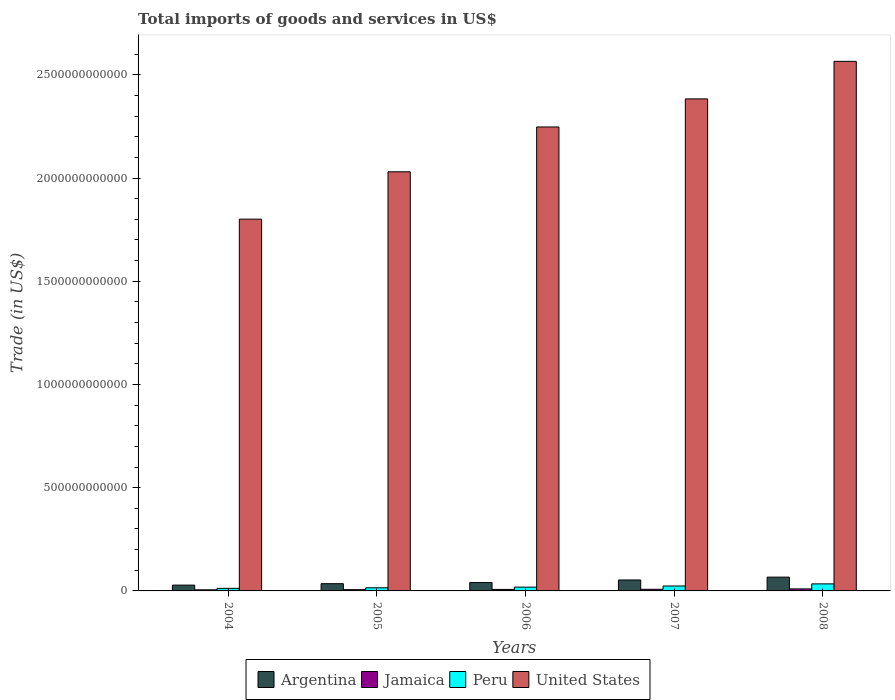How many groups of bars are there?
Offer a very short reply. 5. Are the number of bars per tick equal to the number of legend labels?
Your answer should be compact. Yes. Are the number of bars on each tick of the X-axis equal?
Your answer should be compact. Yes. How many bars are there on the 3rd tick from the right?
Your response must be concise. 4. What is the label of the 2nd group of bars from the left?
Your response must be concise. 2005. What is the total imports of goods and services in Peru in 2006?
Provide a short and direct response. 1.83e+1. Across all years, what is the maximum total imports of goods and services in Jamaica?
Ensure brevity in your answer.  9.80e+09. Across all years, what is the minimum total imports of goods and services in Jamaica?
Provide a short and direct response. 5.26e+09. In which year was the total imports of goods and services in Peru minimum?
Offer a very short reply. 2004. What is the total total imports of goods and services in Argentina in the graph?
Ensure brevity in your answer.  2.24e+11. What is the difference between the total imports of goods and services in Argentina in 2004 and that in 2008?
Keep it short and to the point. -3.87e+1. What is the difference between the total imports of goods and services in United States in 2008 and the total imports of goods and services in Peru in 2004?
Your answer should be compact. 2.55e+12. What is the average total imports of goods and services in Peru per year?
Your response must be concise. 2.08e+1. In the year 2004, what is the difference between the total imports of goods and services in United States and total imports of goods and services in Jamaica?
Give a very brief answer. 1.80e+12. In how many years, is the total imports of goods and services in Peru greater than 1900000000000 US$?
Provide a succinct answer. 0. What is the ratio of the total imports of goods and services in Jamaica in 2004 to that in 2008?
Make the answer very short. 0.54. What is the difference between the highest and the second highest total imports of goods and services in United States?
Your answer should be very brief. 1.82e+11. What is the difference between the highest and the lowest total imports of goods and services in Argentina?
Keep it short and to the point. 3.87e+1. In how many years, is the total imports of goods and services in United States greater than the average total imports of goods and services in United States taken over all years?
Give a very brief answer. 3. Is the sum of the total imports of goods and services in United States in 2007 and 2008 greater than the maximum total imports of goods and services in Argentina across all years?
Keep it short and to the point. Yes. Are all the bars in the graph horizontal?
Make the answer very short. No. How many years are there in the graph?
Your response must be concise. 5. What is the difference between two consecutive major ticks on the Y-axis?
Your response must be concise. 5.00e+11. Does the graph contain any zero values?
Keep it short and to the point. No. How many legend labels are there?
Your response must be concise. 4. How are the legend labels stacked?
Keep it short and to the point. Horizontal. What is the title of the graph?
Keep it short and to the point. Total imports of goods and services in US$. Does "Euro area" appear as one of the legend labels in the graph?
Your response must be concise. No. What is the label or title of the X-axis?
Provide a succinct answer. Years. What is the label or title of the Y-axis?
Your answer should be compact. Trade (in US$). What is the Trade (in US$) in Argentina in 2004?
Provide a succinct answer. 2.81e+1. What is the Trade (in US$) of Jamaica in 2004?
Offer a very short reply. 5.26e+09. What is the Trade (in US$) of Peru in 2004?
Make the answer very short. 1.24e+1. What is the Trade (in US$) in United States in 2004?
Offer a terse response. 1.80e+12. What is the Trade (in US$) in Argentina in 2005?
Keep it short and to the point. 3.51e+1. What is the Trade (in US$) of Jamaica in 2005?
Offer a terse response. 6.19e+09. What is the Trade (in US$) of Peru in 2005?
Your response must be concise. 1.52e+1. What is the Trade (in US$) in United States in 2005?
Offer a very short reply. 2.03e+12. What is the Trade (in US$) of Argentina in 2006?
Your answer should be very brief. 4.09e+1. What is the Trade (in US$) of Jamaica in 2006?
Your answer should be very brief. 7.22e+09. What is the Trade (in US$) of Peru in 2006?
Offer a terse response. 1.83e+1. What is the Trade (in US$) of United States in 2006?
Provide a short and direct response. 2.25e+12. What is the Trade (in US$) in Argentina in 2007?
Ensure brevity in your answer.  5.30e+1. What is the Trade (in US$) of Jamaica in 2007?
Your answer should be compact. 7.89e+09. What is the Trade (in US$) of Peru in 2007?
Provide a succinct answer. 2.39e+1. What is the Trade (in US$) in United States in 2007?
Your answer should be very brief. 2.38e+12. What is the Trade (in US$) of Argentina in 2008?
Your answer should be very brief. 6.68e+1. What is the Trade (in US$) in Jamaica in 2008?
Offer a very short reply. 9.80e+09. What is the Trade (in US$) in Peru in 2008?
Provide a succinct answer. 3.41e+1. What is the Trade (in US$) in United States in 2008?
Your response must be concise. 2.57e+12. Across all years, what is the maximum Trade (in US$) of Argentina?
Your answer should be very brief. 6.68e+1. Across all years, what is the maximum Trade (in US$) of Jamaica?
Keep it short and to the point. 9.80e+09. Across all years, what is the maximum Trade (in US$) in Peru?
Your answer should be very brief. 3.41e+1. Across all years, what is the maximum Trade (in US$) in United States?
Your answer should be very brief. 2.57e+12. Across all years, what is the minimum Trade (in US$) in Argentina?
Your response must be concise. 2.81e+1. Across all years, what is the minimum Trade (in US$) in Jamaica?
Keep it short and to the point. 5.26e+09. Across all years, what is the minimum Trade (in US$) of Peru?
Keep it short and to the point. 1.24e+1. Across all years, what is the minimum Trade (in US$) of United States?
Keep it short and to the point. 1.80e+12. What is the total Trade (in US$) in Argentina in the graph?
Offer a very short reply. 2.24e+11. What is the total Trade (in US$) of Jamaica in the graph?
Provide a succinct answer. 3.63e+1. What is the total Trade (in US$) in Peru in the graph?
Make the answer very short. 1.04e+11. What is the total Trade (in US$) in United States in the graph?
Your answer should be compact. 1.10e+13. What is the difference between the Trade (in US$) in Argentina in 2004 and that in 2005?
Your response must be concise. -6.96e+09. What is the difference between the Trade (in US$) in Jamaica in 2004 and that in 2005?
Offer a very short reply. -9.31e+08. What is the difference between the Trade (in US$) in Peru in 2004 and that in 2005?
Your response must be concise. -2.80e+09. What is the difference between the Trade (in US$) of United States in 2004 and that in 2005?
Make the answer very short. -2.29e+11. What is the difference between the Trade (in US$) of Argentina in 2004 and that in 2006?
Your answer should be compact. -1.27e+1. What is the difference between the Trade (in US$) of Jamaica in 2004 and that in 2006?
Make the answer very short. -1.96e+09. What is the difference between the Trade (in US$) in Peru in 2004 and that in 2006?
Your answer should be very brief. -5.91e+09. What is the difference between the Trade (in US$) in United States in 2004 and that in 2006?
Provide a succinct answer. -4.47e+11. What is the difference between the Trade (in US$) in Argentina in 2004 and that in 2007?
Provide a succinct answer. -2.49e+1. What is the difference between the Trade (in US$) in Jamaica in 2004 and that in 2007?
Your answer should be very brief. -2.63e+09. What is the difference between the Trade (in US$) of Peru in 2004 and that in 2007?
Offer a very short reply. -1.15e+1. What is the difference between the Trade (in US$) of United States in 2004 and that in 2007?
Provide a short and direct response. -5.82e+11. What is the difference between the Trade (in US$) of Argentina in 2004 and that in 2008?
Give a very brief answer. -3.87e+1. What is the difference between the Trade (in US$) of Jamaica in 2004 and that in 2008?
Keep it short and to the point. -4.54e+09. What is the difference between the Trade (in US$) of Peru in 2004 and that in 2008?
Give a very brief answer. -2.17e+1. What is the difference between the Trade (in US$) in United States in 2004 and that in 2008?
Offer a very short reply. -7.64e+11. What is the difference between the Trade (in US$) of Argentina in 2005 and that in 2006?
Your answer should be very brief. -5.76e+09. What is the difference between the Trade (in US$) in Jamaica in 2005 and that in 2006?
Make the answer very short. -1.03e+09. What is the difference between the Trade (in US$) in Peru in 2005 and that in 2006?
Provide a succinct answer. -3.11e+09. What is the difference between the Trade (in US$) of United States in 2005 and that in 2006?
Keep it short and to the point. -2.17e+11. What is the difference between the Trade (in US$) in Argentina in 2005 and that in 2007?
Your answer should be compact. -1.80e+1. What is the difference between the Trade (in US$) of Jamaica in 2005 and that in 2007?
Your answer should be compact. -1.70e+09. What is the difference between the Trade (in US$) of Peru in 2005 and that in 2007?
Offer a very short reply. -8.67e+09. What is the difference between the Trade (in US$) of United States in 2005 and that in 2007?
Make the answer very short. -3.53e+11. What is the difference between the Trade (in US$) in Argentina in 2005 and that in 2008?
Provide a short and direct response. -3.17e+1. What is the difference between the Trade (in US$) in Jamaica in 2005 and that in 2008?
Your answer should be very brief. -3.61e+09. What is the difference between the Trade (in US$) of Peru in 2005 and that in 2008?
Your response must be concise. -1.89e+1. What is the difference between the Trade (in US$) in United States in 2005 and that in 2008?
Ensure brevity in your answer.  -5.35e+11. What is the difference between the Trade (in US$) in Argentina in 2006 and that in 2007?
Offer a terse response. -1.22e+1. What is the difference between the Trade (in US$) of Jamaica in 2006 and that in 2007?
Provide a short and direct response. -6.72e+08. What is the difference between the Trade (in US$) of Peru in 2006 and that in 2007?
Your response must be concise. -5.56e+09. What is the difference between the Trade (in US$) of United States in 2006 and that in 2007?
Ensure brevity in your answer.  -1.36e+11. What is the difference between the Trade (in US$) of Argentina in 2006 and that in 2008?
Your answer should be very brief. -2.59e+1. What is the difference between the Trade (in US$) in Jamaica in 2006 and that in 2008?
Offer a very short reply. -2.58e+09. What is the difference between the Trade (in US$) of Peru in 2006 and that in 2008?
Your answer should be compact. -1.58e+1. What is the difference between the Trade (in US$) of United States in 2006 and that in 2008?
Ensure brevity in your answer.  -3.18e+11. What is the difference between the Trade (in US$) in Argentina in 2007 and that in 2008?
Offer a terse response. -1.37e+1. What is the difference between the Trade (in US$) of Jamaica in 2007 and that in 2008?
Offer a terse response. -1.91e+09. What is the difference between the Trade (in US$) in Peru in 2007 and that in 2008?
Offer a terse response. -1.02e+1. What is the difference between the Trade (in US$) in United States in 2007 and that in 2008?
Provide a short and direct response. -1.82e+11. What is the difference between the Trade (in US$) of Argentina in 2004 and the Trade (in US$) of Jamaica in 2005?
Your response must be concise. 2.20e+1. What is the difference between the Trade (in US$) in Argentina in 2004 and the Trade (in US$) in Peru in 2005?
Keep it short and to the point. 1.29e+1. What is the difference between the Trade (in US$) in Argentina in 2004 and the Trade (in US$) in United States in 2005?
Give a very brief answer. -2.00e+12. What is the difference between the Trade (in US$) of Jamaica in 2004 and the Trade (in US$) of Peru in 2005?
Offer a very short reply. -9.96e+09. What is the difference between the Trade (in US$) in Jamaica in 2004 and the Trade (in US$) in United States in 2005?
Ensure brevity in your answer.  -2.02e+12. What is the difference between the Trade (in US$) of Peru in 2004 and the Trade (in US$) of United States in 2005?
Keep it short and to the point. -2.02e+12. What is the difference between the Trade (in US$) of Argentina in 2004 and the Trade (in US$) of Jamaica in 2006?
Your answer should be compact. 2.09e+1. What is the difference between the Trade (in US$) in Argentina in 2004 and the Trade (in US$) in Peru in 2006?
Your answer should be very brief. 9.81e+09. What is the difference between the Trade (in US$) of Argentina in 2004 and the Trade (in US$) of United States in 2006?
Provide a short and direct response. -2.22e+12. What is the difference between the Trade (in US$) in Jamaica in 2004 and the Trade (in US$) in Peru in 2006?
Provide a succinct answer. -1.31e+1. What is the difference between the Trade (in US$) of Jamaica in 2004 and the Trade (in US$) of United States in 2006?
Your answer should be very brief. -2.24e+12. What is the difference between the Trade (in US$) in Peru in 2004 and the Trade (in US$) in United States in 2006?
Your response must be concise. -2.23e+12. What is the difference between the Trade (in US$) in Argentina in 2004 and the Trade (in US$) in Jamaica in 2007?
Your response must be concise. 2.02e+1. What is the difference between the Trade (in US$) in Argentina in 2004 and the Trade (in US$) in Peru in 2007?
Your answer should be compact. 4.25e+09. What is the difference between the Trade (in US$) in Argentina in 2004 and the Trade (in US$) in United States in 2007?
Provide a short and direct response. -2.36e+12. What is the difference between the Trade (in US$) of Jamaica in 2004 and the Trade (in US$) of Peru in 2007?
Your answer should be very brief. -1.86e+1. What is the difference between the Trade (in US$) in Jamaica in 2004 and the Trade (in US$) in United States in 2007?
Your response must be concise. -2.38e+12. What is the difference between the Trade (in US$) of Peru in 2004 and the Trade (in US$) of United States in 2007?
Provide a short and direct response. -2.37e+12. What is the difference between the Trade (in US$) in Argentina in 2004 and the Trade (in US$) in Jamaica in 2008?
Your answer should be very brief. 1.83e+1. What is the difference between the Trade (in US$) in Argentina in 2004 and the Trade (in US$) in Peru in 2008?
Give a very brief answer. -5.99e+09. What is the difference between the Trade (in US$) of Argentina in 2004 and the Trade (in US$) of United States in 2008?
Offer a terse response. -2.54e+12. What is the difference between the Trade (in US$) in Jamaica in 2004 and the Trade (in US$) in Peru in 2008?
Provide a succinct answer. -2.89e+1. What is the difference between the Trade (in US$) in Jamaica in 2004 and the Trade (in US$) in United States in 2008?
Your response must be concise. -2.56e+12. What is the difference between the Trade (in US$) of Peru in 2004 and the Trade (in US$) of United States in 2008?
Provide a succinct answer. -2.55e+12. What is the difference between the Trade (in US$) of Argentina in 2005 and the Trade (in US$) of Jamaica in 2006?
Give a very brief answer. 2.79e+1. What is the difference between the Trade (in US$) of Argentina in 2005 and the Trade (in US$) of Peru in 2006?
Keep it short and to the point. 1.68e+1. What is the difference between the Trade (in US$) of Argentina in 2005 and the Trade (in US$) of United States in 2006?
Offer a very short reply. -2.21e+12. What is the difference between the Trade (in US$) in Jamaica in 2005 and the Trade (in US$) in Peru in 2006?
Your answer should be compact. -1.21e+1. What is the difference between the Trade (in US$) in Jamaica in 2005 and the Trade (in US$) in United States in 2006?
Ensure brevity in your answer.  -2.24e+12. What is the difference between the Trade (in US$) in Peru in 2005 and the Trade (in US$) in United States in 2006?
Your answer should be compact. -2.23e+12. What is the difference between the Trade (in US$) of Argentina in 2005 and the Trade (in US$) of Jamaica in 2007?
Give a very brief answer. 2.72e+1. What is the difference between the Trade (in US$) of Argentina in 2005 and the Trade (in US$) of Peru in 2007?
Keep it short and to the point. 1.12e+1. What is the difference between the Trade (in US$) of Argentina in 2005 and the Trade (in US$) of United States in 2007?
Your answer should be very brief. -2.35e+12. What is the difference between the Trade (in US$) of Jamaica in 2005 and the Trade (in US$) of Peru in 2007?
Ensure brevity in your answer.  -1.77e+1. What is the difference between the Trade (in US$) in Jamaica in 2005 and the Trade (in US$) in United States in 2007?
Your response must be concise. -2.38e+12. What is the difference between the Trade (in US$) in Peru in 2005 and the Trade (in US$) in United States in 2007?
Ensure brevity in your answer.  -2.37e+12. What is the difference between the Trade (in US$) in Argentina in 2005 and the Trade (in US$) in Jamaica in 2008?
Ensure brevity in your answer.  2.53e+1. What is the difference between the Trade (in US$) of Argentina in 2005 and the Trade (in US$) of Peru in 2008?
Keep it short and to the point. 9.65e+08. What is the difference between the Trade (in US$) in Argentina in 2005 and the Trade (in US$) in United States in 2008?
Offer a terse response. -2.53e+12. What is the difference between the Trade (in US$) in Jamaica in 2005 and the Trade (in US$) in Peru in 2008?
Make the answer very short. -2.79e+1. What is the difference between the Trade (in US$) in Jamaica in 2005 and the Trade (in US$) in United States in 2008?
Ensure brevity in your answer.  -2.56e+12. What is the difference between the Trade (in US$) in Peru in 2005 and the Trade (in US$) in United States in 2008?
Your response must be concise. -2.55e+12. What is the difference between the Trade (in US$) in Argentina in 2006 and the Trade (in US$) in Jamaica in 2007?
Your response must be concise. 3.30e+1. What is the difference between the Trade (in US$) in Argentina in 2006 and the Trade (in US$) in Peru in 2007?
Offer a terse response. 1.70e+1. What is the difference between the Trade (in US$) in Argentina in 2006 and the Trade (in US$) in United States in 2007?
Provide a succinct answer. -2.34e+12. What is the difference between the Trade (in US$) of Jamaica in 2006 and the Trade (in US$) of Peru in 2007?
Provide a succinct answer. -1.67e+1. What is the difference between the Trade (in US$) in Jamaica in 2006 and the Trade (in US$) in United States in 2007?
Your answer should be very brief. -2.38e+12. What is the difference between the Trade (in US$) in Peru in 2006 and the Trade (in US$) in United States in 2007?
Offer a terse response. -2.36e+12. What is the difference between the Trade (in US$) in Argentina in 2006 and the Trade (in US$) in Jamaica in 2008?
Your response must be concise. 3.11e+1. What is the difference between the Trade (in US$) in Argentina in 2006 and the Trade (in US$) in Peru in 2008?
Ensure brevity in your answer.  6.72e+09. What is the difference between the Trade (in US$) in Argentina in 2006 and the Trade (in US$) in United States in 2008?
Your response must be concise. -2.52e+12. What is the difference between the Trade (in US$) in Jamaica in 2006 and the Trade (in US$) in Peru in 2008?
Provide a succinct answer. -2.69e+1. What is the difference between the Trade (in US$) of Jamaica in 2006 and the Trade (in US$) of United States in 2008?
Ensure brevity in your answer.  -2.56e+12. What is the difference between the Trade (in US$) in Peru in 2006 and the Trade (in US$) in United States in 2008?
Your answer should be very brief. -2.55e+12. What is the difference between the Trade (in US$) in Argentina in 2007 and the Trade (in US$) in Jamaica in 2008?
Give a very brief answer. 4.33e+1. What is the difference between the Trade (in US$) in Argentina in 2007 and the Trade (in US$) in Peru in 2008?
Offer a very short reply. 1.89e+1. What is the difference between the Trade (in US$) of Argentina in 2007 and the Trade (in US$) of United States in 2008?
Your response must be concise. -2.51e+12. What is the difference between the Trade (in US$) in Jamaica in 2007 and the Trade (in US$) in Peru in 2008?
Make the answer very short. -2.62e+1. What is the difference between the Trade (in US$) of Jamaica in 2007 and the Trade (in US$) of United States in 2008?
Offer a terse response. -2.56e+12. What is the difference between the Trade (in US$) in Peru in 2007 and the Trade (in US$) in United States in 2008?
Your response must be concise. -2.54e+12. What is the average Trade (in US$) of Argentina per year?
Your response must be concise. 4.48e+1. What is the average Trade (in US$) of Jamaica per year?
Offer a very short reply. 7.27e+09. What is the average Trade (in US$) in Peru per year?
Give a very brief answer. 2.08e+1. What is the average Trade (in US$) in United States per year?
Provide a succinct answer. 2.21e+12. In the year 2004, what is the difference between the Trade (in US$) in Argentina and Trade (in US$) in Jamaica?
Provide a short and direct response. 2.29e+1. In the year 2004, what is the difference between the Trade (in US$) of Argentina and Trade (in US$) of Peru?
Provide a short and direct response. 1.57e+1. In the year 2004, what is the difference between the Trade (in US$) of Argentina and Trade (in US$) of United States?
Provide a short and direct response. -1.77e+12. In the year 2004, what is the difference between the Trade (in US$) of Jamaica and Trade (in US$) of Peru?
Offer a terse response. -7.16e+09. In the year 2004, what is the difference between the Trade (in US$) in Jamaica and Trade (in US$) in United States?
Offer a very short reply. -1.80e+12. In the year 2004, what is the difference between the Trade (in US$) of Peru and Trade (in US$) of United States?
Your answer should be compact. -1.79e+12. In the year 2005, what is the difference between the Trade (in US$) of Argentina and Trade (in US$) of Jamaica?
Keep it short and to the point. 2.89e+1. In the year 2005, what is the difference between the Trade (in US$) in Argentina and Trade (in US$) in Peru?
Your response must be concise. 1.99e+1. In the year 2005, what is the difference between the Trade (in US$) in Argentina and Trade (in US$) in United States?
Offer a terse response. -1.99e+12. In the year 2005, what is the difference between the Trade (in US$) in Jamaica and Trade (in US$) in Peru?
Provide a succinct answer. -9.03e+09. In the year 2005, what is the difference between the Trade (in US$) of Jamaica and Trade (in US$) of United States?
Provide a short and direct response. -2.02e+12. In the year 2005, what is the difference between the Trade (in US$) of Peru and Trade (in US$) of United States?
Provide a succinct answer. -2.01e+12. In the year 2006, what is the difference between the Trade (in US$) of Argentina and Trade (in US$) of Jamaica?
Your response must be concise. 3.36e+1. In the year 2006, what is the difference between the Trade (in US$) of Argentina and Trade (in US$) of Peru?
Give a very brief answer. 2.25e+1. In the year 2006, what is the difference between the Trade (in US$) in Argentina and Trade (in US$) in United States?
Make the answer very short. -2.21e+12. In the year 2006, what is the difference between the Trade (in US$) in Jamaica and Trade (in US$) in Peru?
Ensure brevity in your answer.  -1.11e+1. In the year 2006, what is the difference between the Trade (in US$) of Jamaica and Trade (in US$) of United States?
Your answer should be compact. -2.24e+12. In the year 2006, what is the difference between the Trade (in US$) in Peru and Trade (in US$) in United States?
Offer a terse response. -2.23e+12. In the year 2007, what is the difference between the Trade (in US$) in Argentina and Trade (in US$) in Jamaica?
Ensure brevity in your answer.  4.52e+1. In the year 2007, what is the difference between the Trade (in US$) in Argentina and Trade (in US$) in Peru?
Your response must be concise. 2.92e+1. In the year 2007, what is the difference between the Trade (in US$) in Argentina and Trade (in US$) in United States?
Your answer should be compact. -2.33e+12. In the year 2007, what is the difference between the Trade (in US$) in Jamaica and Trade (in US$) in Peru?
Your answer should be compact. -1.60e+1. In the year 2007, what is the difference between the Trade (in US$) of Jamaica and Trade (in US$) of United States?
Offer a terse response. -2.38e+12. In the year 2007, what is the difference between the Trade (in US$) of Peru and Trade (in US$) of United States?
Give a very brief answer. -2.36e+12. In the year 2008, what is the difference between the Trade (in US$) in Argentina and Trade (in US$) in Jamaica?
Offer a terse response. 5.70e+1. In the year 2008, what is the difference between the Trade (in US$) in Argentina and Trade (in US$) in Peru?
Your answer should be very brief. 3.27e+1. In the year 2008, what is the difference between the Trade (in US$) in Argentina and Trade (in US$) in United States?
Ensure brevity in your answer.  -2.50e+12. In the year 2008, what is the difference between the Trade (in US$) in Jamaica and Trade (in US$) in Peru?
Your answer should be very brief. -2.43e+1. In the year 2008, what is the difference between the Trade (in US$) of Jamaica and Trade (in US$) of United States?
Your response must be concise. -2.56e+12. In the year 2008, what is the difference between the Trade (in US$) in Peru and Trade (in US$) in United States?
Make the answer very short. -2.53e+12. What is the ratio of the Trade (in US$) in Argentina in 2004 to that in 2005?
Your answer should be very brief. 0.8. What is the ratio of the Trade (in US$) of Jamaica in 2004 to that in 2005?
Offer a terse response. 0.85. What is the ratio of the Trade (in US$) in Peru in 2004 to that in 2005?
Offer a very short reply. 0.82. What is the ratio of the Trade (in US$) in United States in 2004 to that in 2005?
Your answer should be very brief. 0.89. What is the ratio of the Trade (in US$) in Argentina in 2004 to that in 2006?
Your answer should be compact. 0.69. What is the ratio of the Trade (in US$) of Jamaica in 2004 to that in 2006?
Keep it short and to the point. 0.73. What is the ratio of the Trade (in US$) of Peru in 2004 to that in 2006?
Offer a terse response. 0.68. What is the ratio of the Trade (in US$) in United States in 2004 to that in 2006?
Give a very brief answer. 0.8. What is the ratio of the Trade (in US$) in Argentina in 2004 to that in 2007?
Make the answer very short. 0.53. What is the ratio of the Trade (in US$) of Jamaica in 2004 to that in 2007?
Ensure brevity in your answer.  0.67. What is the ratio of the Trade (in US$) of Peru in 2004 to that in 2007?
Provide a short and direct response. 0.52. What is the ratio of the Trade (in US$) of United States in 2004 to that in 2007?
Your answer should be very brief. 0.76. What is the ratio of the Trade (in US$) in Argentina in 2004 to that in 2008?
Keep it short and to the point. 0.42. What is the ratio of the Trade (in US$) in Jamaica in 2004 to that in 2008?
Make the answer very short. 0.54. What is the ratio of the Trade (in US$) of Peru in 2004 to that in 2008?
Your answer should be compact. 0.36. What is the ratio of the Trade (in US$) of United States in 2004 to that in 2008?
Keep it short and to the point. 0.7. What is the ratio of the Trade (in US$) of Argentina in 2005 to that in 2006?
Ensure brevity in your answer.  0.86. What is the ratio of the Trade (in US$) in Jamaica in 2005 to that in 2006?
Offer a very short reply. 0.86. What is the ratio of the Trade (in US$) in Peru in 2005 to that in 2006?
Your response must be concise. 0.83. What is the ratio of the Trade (in US$) in United States in 2005 to that in 2006?
Provide a short and direct response. 0.9. What is the ratio of the Trade (in US$) of Argentina in 2005 to that in 2007?
Your response must be concise. 0.66. What is the ratio of the Trade (in US$) in Jamaica in 2005 to that in 2007?
Your answer should be compact. 0.78. What is the ratio of the Trade (in US$) in Peru in 2005 to that in 2007?
Your answer should be compact. 0.64. What is the ratio of the Trade (in US$) in United States in 2005 to that in 2007?
Provide a short and direct response. 0.85. What is the ratio of the Trade (in US$) of Argentina in 2005 to that in 2008?
Your response must be concise. 0.53. What is the ratio of the Trade (in US$) in Jamaica in 2005 to that in 2008?
Your response must be concise. 0.63. What is the ratio of the Trade (in US$) of Peru in 2005 to that in 2008?
Offer a terse response. 0.45. What is the ratio of the Trade (in US$) of United States in 2005 to that in 2008?
Offer a terse response. 0.79. What is the ratio of the Trade (in US$) of Argentina in 2006 to that in 2007?
Keep it short and to the point. 0.77. What is the ratio of the Trade (in US$) of Jamaica in 2006 to that in 2007?
Ensure brevity in your answer.  0.91. What is the ratio of the Trade (in US$) in Peru in 2006 to that in 2007?
Give a very brief answer. 0.77. What is the ratio of the Trade (in US$) in United States in 2006 to that in 2007?
Provide a short and direct response. 0.94. What is the ratio of the Trade (in US$) of Argentina in 2006 to that in 2008?
Provide a short and direct response. 0.61. What is the ratio of the Trade (in US$) in Jamaica in 2006 to that in 2008?
Your response must be concise. 0.74. What is the ratio of the Trade (in US$) in Peru in 2006 to that in 2008?
Ensure brevity in your answer.  0.54. What is the ratio of the Trade (in US$) of United States in 2006 to that in 2008?
Ensure brevity in your answer.  0.88. What is the ratio of the Trade (in US$) in Argentina in 2007 to that in 2008?
Your answer should be very brief. 0.79. What is the ratio of the Trade (in US$) of Jamaica in 2007 to that in 2008?
Offer a very short reply. 0.81. What is the ratio of the Trade (in US$) in Peru in 2007 to that in 2008?
Ensure brevity in your answer.  0.7. What is the ratio of the Trade (in US$) of United States in 2007 to that in 2008?
Offer a very short reply. 0.93. What is the difference between the highest and the second highest Trade (in US$) in Argentina?
Give a very brief answer. 1.37e+1. What is the difference between the highest and the second highest Trade (in US$) of Jamaica?
Your answer should be very brief. 1.91e+09. What is the difference between the highest and the second highest Trade (in US$) of Peru?
Your answer should be very brief. 1.02e+1. What is the difference between the highest and the second highest Trade (in US$) of United States?
Your answer should be compact. 1.82e+11. What is the difference between the highest and the lowest Trade (in US$) of Argentina?
Ensure brevity in your answer.  3.87e+1. What is the difference between the highest and the lowest Trade (in US$) of Jamaica?
Provide a short and direct response. 4.54e+09. What is the difference between the highest and the lowest Trade (in US$) of Peru?
Offer a terse response. 2.17e+1. What is the difference between the highest and the lowest Trade (in US$) in United States?
Make the answer very short. 7.64e+11. 